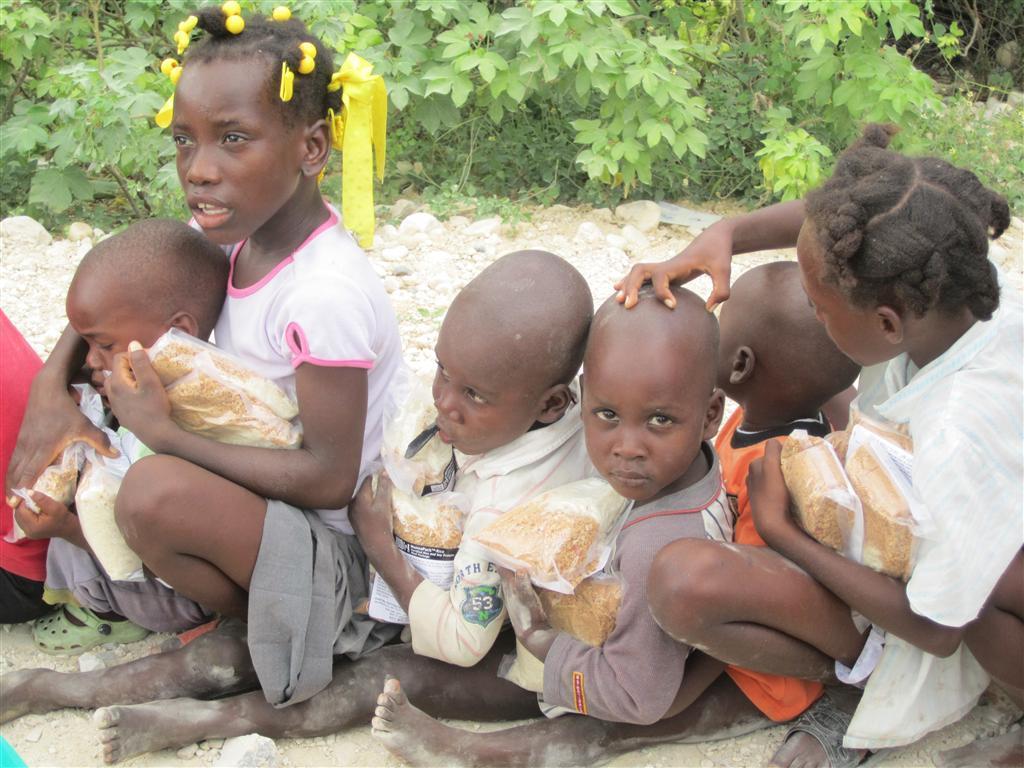Can you describe this image briefly? In this image we can see few children are sitting on the ground and they are holding packets. In the background we can see plants. 